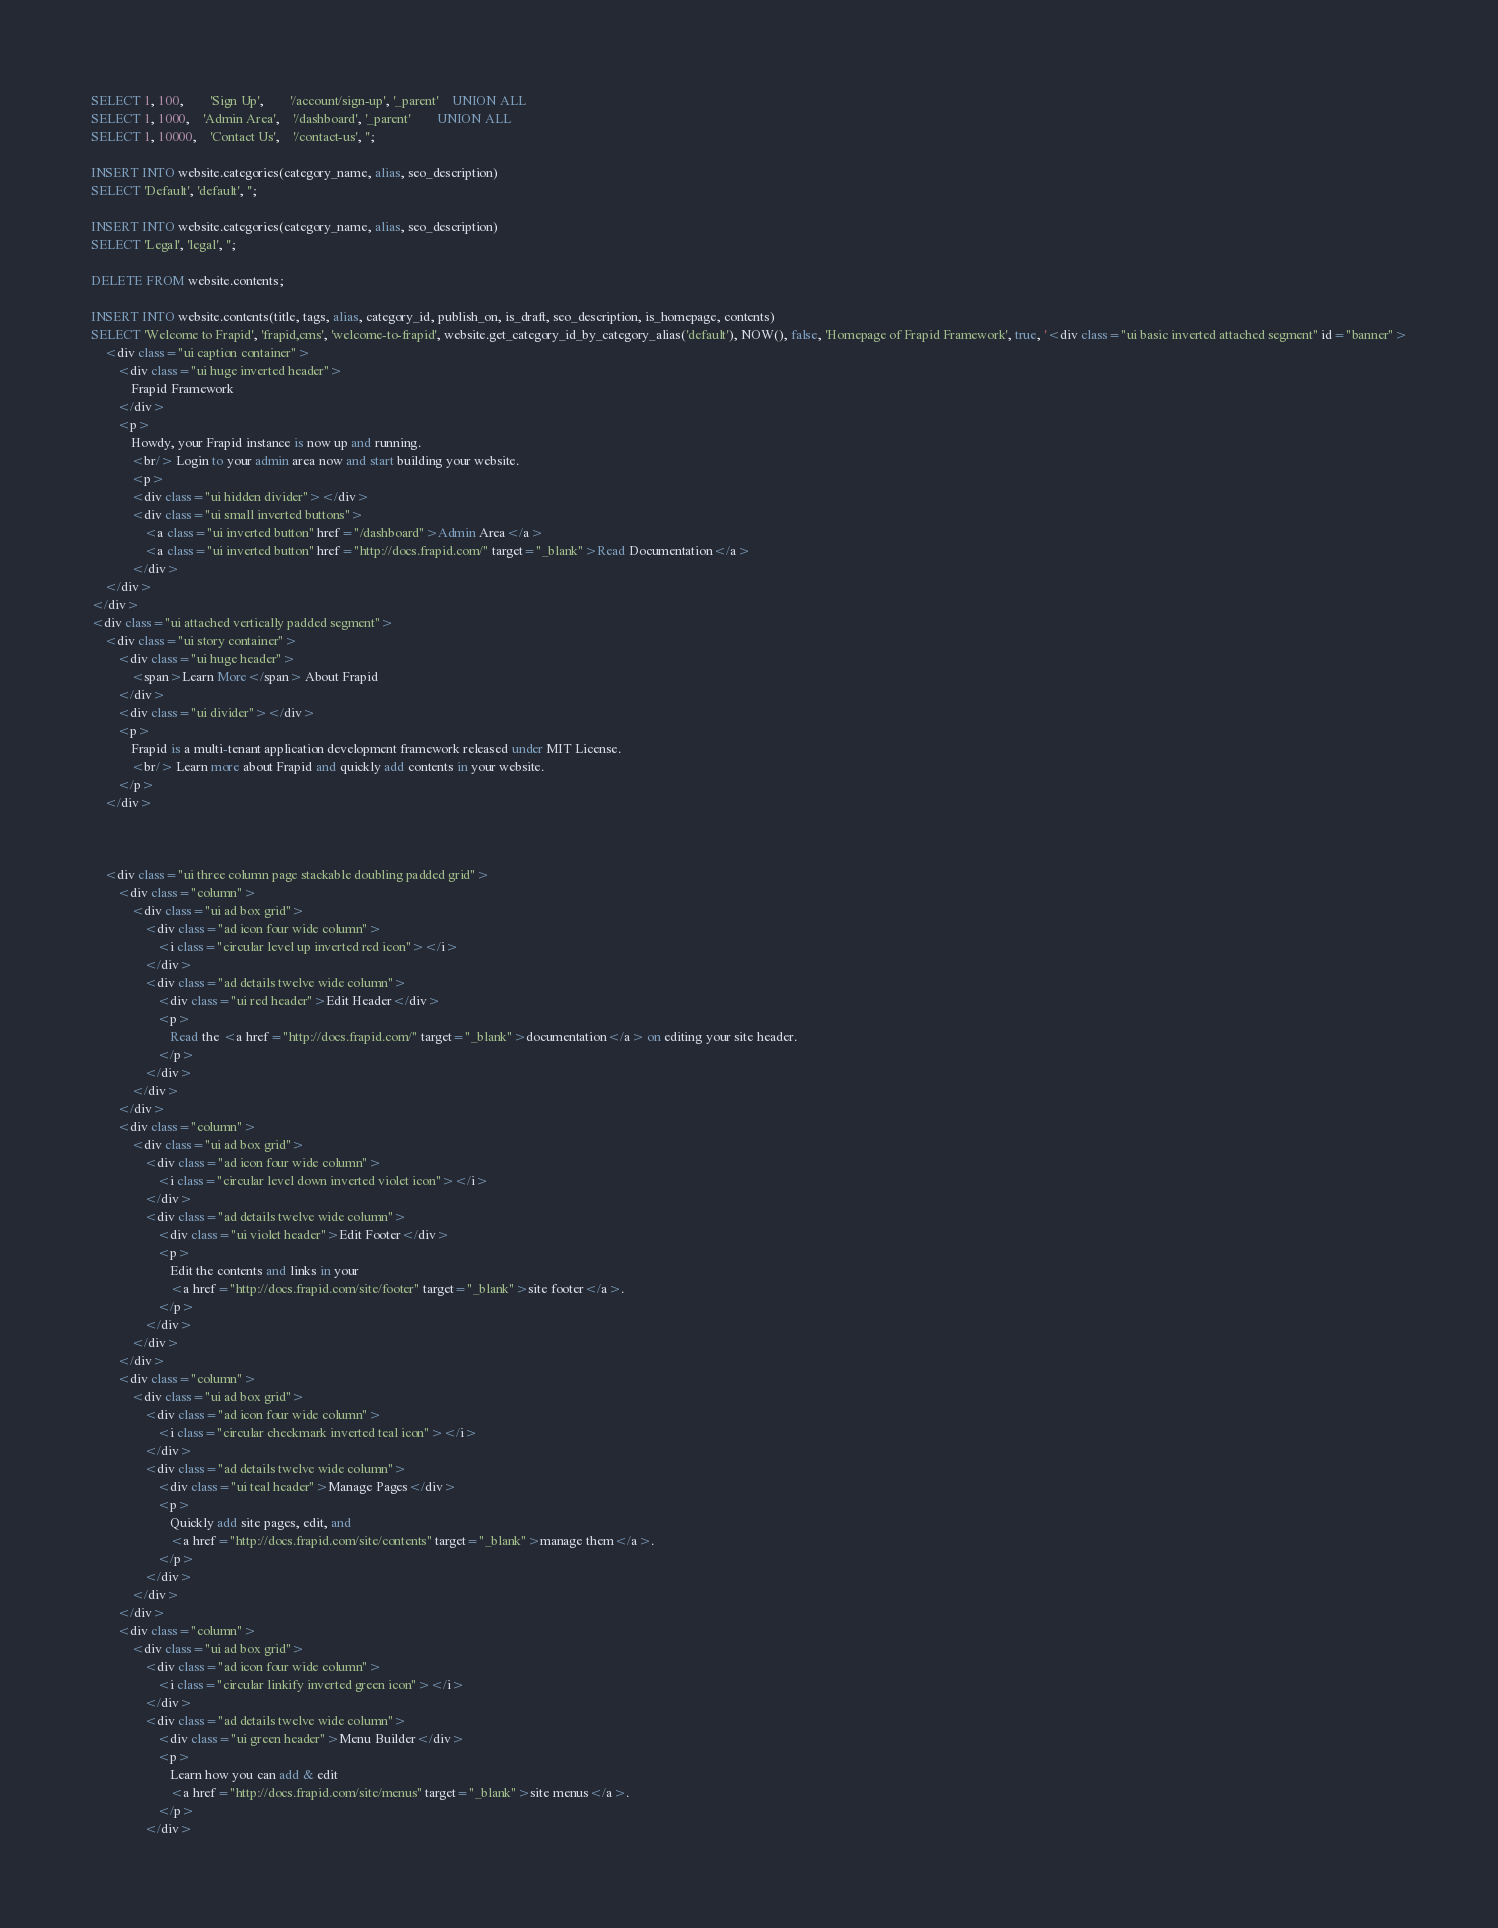Convert code to text. <code><loc_0><loc_0><loc_500><loc_500><_SQL_>SELECT 1, 100, 		'Sign Up', 		'/account/sign-up', '_parent' 	UNION ALL
SELECT 1, 1000, 	'Admin Area', 	'/dashboard', '_parent' 		UNION ALL
SELECT 1, 10000,	'Contact Us', 	'/contact-us', '';

INSERT INTO website.categories(category_name, alias, seo_description)
SELECT 'Default', 'default', '';

INSERT INTO website.categories(category_name, alias, seo_description)
SELECT 'Legal', 'legal', '';

DELETE FROM website.contents;

INSERT INTO website.contents(title, tags, alias, category_id, publish_on, is_draft, seo_description, is_homepage, contents)
SELECT 'Welcome to Frapid', 'frapid,cms', 'welcome-to-frapid', website.get_category_id_by_category_alias('default'), NOW(), false, 'Homepage of Frapid Framework', true, '<div class="ui basic inverted attached segment" id="banner">
    <div class="ui caption container">
        <div class="ui huge inverted header">
            Frapid Framework
        </div>
        <p>
            Howdy, your Frapid instance is now up and running.
            <br/> Login to your admin area now and start building your website.
            <p>
            <div class="ui hidden divider"></div>
            <div class="ui small inverted buttons">
                <a class="ui inverted button" href="/dashboard">Admin Area</a>
                <a class="ui inverted button" href="http://docs.frapid.com/" target="_blank">Read Documentation</a>
            </div>
    </div>
</div>
<div class="ui attached vertically padded segment">
    <div class="ui story container">
        <div class="ui huge header">
            <span>Learn More</span> About Frapid
        </div>
        <div class="ui divider"></div>
        <p>
            Frapid is a multi-tenant application development framework released under MIT License.
            <br/> Learn more about Frapid and quickly add contents in your website.
        </p>
    </div>



    <div class="ui three column page stackable doubling padded grid">
        <div class="column">
            <div class="ui ad box grid">
                <div class="ad icon four wide column">
                    <i class="circular level up inverted red icon"></i>
                </div>
                <div class="ad details twelve wide column">
                    <div class="ui red header">Edit Header</div>
                    <p>
                        Read the <a href="http://docs.frapid.com/" target="_blank">documentation</a> on editing your site header.
                    </p>
                </div>
            </div>
        </div>
        <div class="column">
            <div class="ui ad box grid">
                <div class="ad icon four wide column">
                    <i class="circular level down inverted violet icon"></i>
                </div>
                <div class="ad details twelve wide column">
                    <div class="ui violet header">Edit Footer</div>
                    <p>
                        Edit the contents and links in your
                        <a href="http://docs.frapid.com/site/footer" target="_blank">site footer</a>.
                    </p>
                </div>
            </div>
        </div>
        <div class="column">
            <div class="ui ad box grid">
                <div class="ad icon four wide column">
                    <i class="circular checkmark inverted teal icon"></i>
                </div>
                <div class="ad details twelve wide column">
                    <div class="ui teal header">Manage Pages</div>
                    <p>
                        Quickly add site pages, edit, and
                        <a href="http://docs.frapid.com/site/contents" target="_blank">manage them</a>.
                    </p>
                </div>
            </div>
        </div>
        <div class="column">
            <div class="ui ad box grid">
                <div class="ad icon four wide column">
                    <i class="circular linkify inverted green icon"></i>
                </div>
                <div class="ad details twelve wide column">
                    <div class="ui green header">Menu Builder</div>
                    <p>
                        Learn how you can add & edit
                        <a href="http://docs.frapid.com/site/menus" target="_blank">site menus</a>.
                    </p>
                </div></code> 